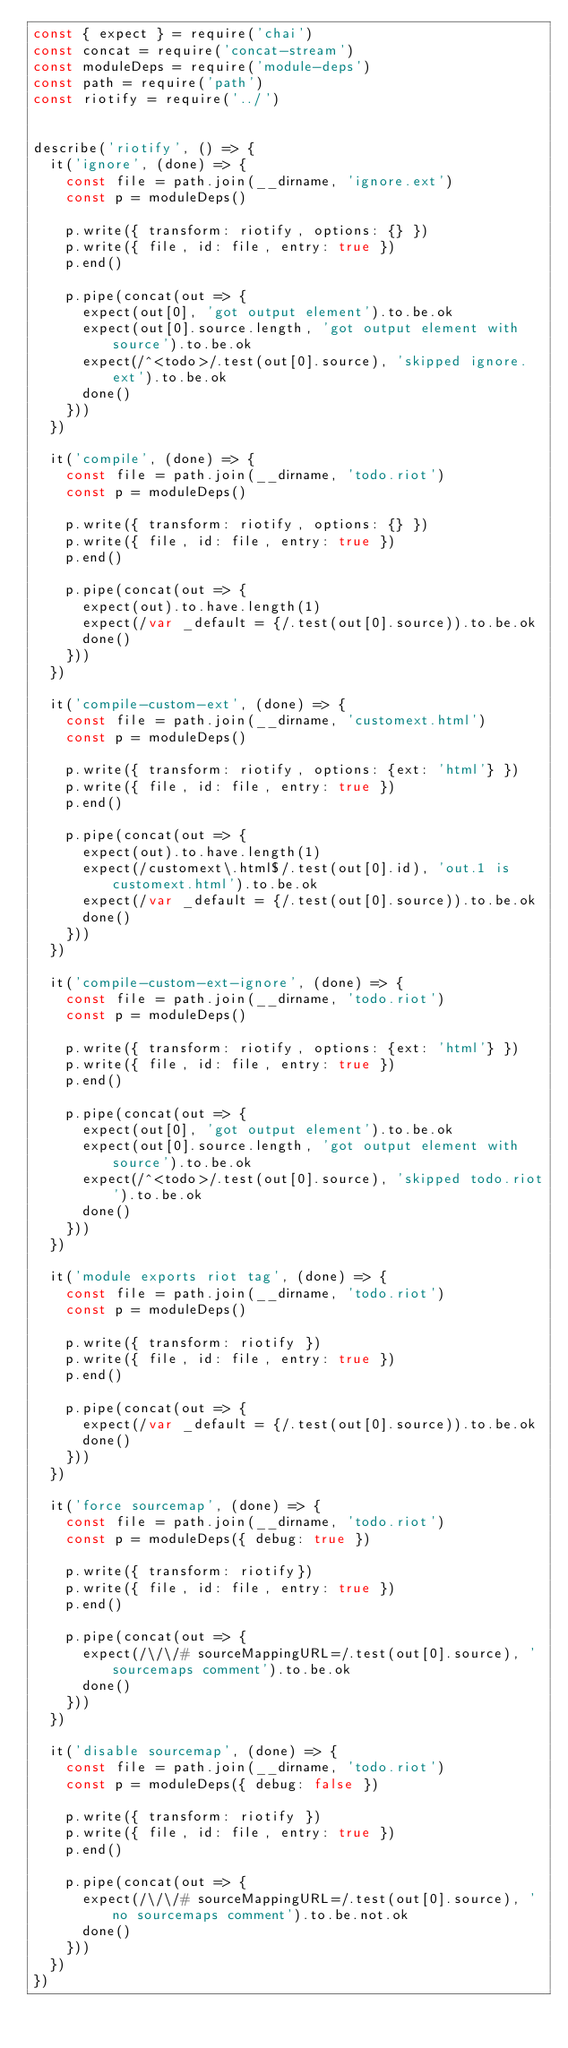<code> <loc_0><loc_0><loc_500><loc_500><_JavaScript_>const { expect } = require('chai')
const concat = require('concat-stream')
const moduleDeps = require('module-deps')
const path = require('path')
const riotify = require('../')


describe('riotify', () => {
  it('ignore', (done) => {
    const file = path.join(__dirname, 'ignore.ext')
    const p = moduleDeps()

    p.write({ transform: riotify, options: {} })
    p.write({ file, id: file, entry: true })
    p.end()

    p.pipe(concat(out => {
      expect(out[0], 'got output element').to.be.ok
      expect(out[0].source.length, 'got output element with source').to.be.ok
      expect(/^<todo>/.test(out[0].source), 'skipped ignore.ext').to.be.ok
      done()
    }))
  })

  it('compile', (done) => {
    const file = path.join(__dirname, 'todo.riot')
    const p = moduleDeps()

    p.write({ transform: riotify, options: {} })
    p.write({ file, id: file, entry: true })
    p.end()

    p.pipe(concat(out => {
      expect(out).to.have.length(1)
      expect(/var _default = {/.test(out[0].source)).to.be.ok
      done()
    }))
  })

  it('compile-custom-ext', (done) => {
    const file = path.join(__dirname, 'customext.html')
    const p = moduleDeps()

    p.write({ transform: riotify, options: {ext: 'html'} })
    p.write({ file, id: file, entry: true })
    p.end()

    p.pipe(concat(out => {
      expect(out).to.have.length(1)
      expect(/customext\.html$/.test(out[0].id), 'out.1 is customext.html').to.be.ok
      expect(/var _default = {/.test(out[0].source)).to.be.ok
      done()
    }))
  })

  it('compile-custom-ext-ignore', (done) => {
    const file = path.join(__dirname, 'todo.riot')
    const p = moduleDeps()

    p.write({ transform: riotify, options: {ext: 'html'} })
    p.write({ file, id: file, entry: true })
    p.end()

    p.pipe(concat(out => {
      expect(out[0], 'got output element').to.be.ok
      expect(out[0].source.length, 'got output element with source').to.be.ok
      expect(/^<todo>/.test(out[0].source), 'skipped todo.riot').to.be.ok
      done()
    }))
  })

  it('module exports riot tag', (done) => {
    const file = path.join(__dirname, 'todo.riot')
    const p = moduleDeps()

    p.write({ transform: riotify })
    p.write({ file, id: file, entry: true })
    p.end()

    p.pipe(concat(out => {
      expect(/var _default = {/.test(out[0].source)).to.be.ok
      done()
    }))
  })

  it('force sourcemap', (done) => {
    const file = path.join(__dirname, 'todo.riot')
    const p = moduleDeps({ debug: true })

    p.write({ transform: riotify})
    p.write({ file, id: file, entry: true })
    p.end()

    p.pipe(concat(out => {
      expect(/\/\/# sourceMappingURL=/.test(out[0].source), 'sourcemaps comment').to.be.ok
      done()
    }))
  })

  it('disable sourcemap', (done) => {
    const file = path.join(__dirname, 'todo.riot')
    const p = moduleDeps({ debug: false })

    p.write({ transform: riotify })
    p.write({ file, id: file, entry: true })
    p.end()

    p.pipe(concat(out => {
      expect(/\/\/# sourceMappingURL=/.test(out[0].source), 'no sourcemaps comment').to.be.not.ok
      done()
    }))
  })
})


</code> 